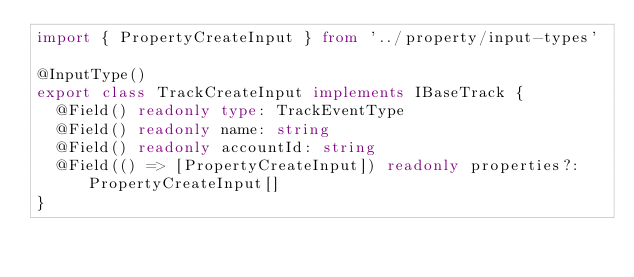<code> <loc_0><loc_0><loc_500><loc_500><_TypeScript_>import { PropertyCreateInput } from '../property/input-types'

@InputType()
export class TrackCreateInput implements IBaseTrack {
  @Field() readonly type: TrackEventType
  @Field() readonly name: string
  @Field() readonly accountId: string
  @Field(() => [PropertyCreateInput]) readonly properties?: PropertyCreateInput[]
}
</code> 